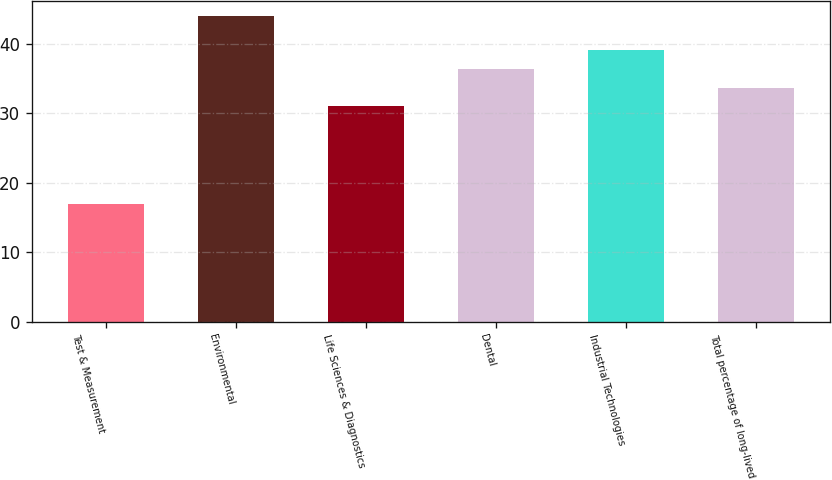Convert chart to OTSL. <chart><loc_0><loc_0><loc_500><loc_500><bar_chart><fcel>Test & Measurement<fcel>Environmental<fcel>Life Sciences & Diagnostics<fcel>Dental<fcel>Industrial Technologies<fcel>Total percentage of long-lived<nl><fcel>17<fcel>44<fcel>31<fcel>36.4<fcel>39.1<fcel>33.7<nl></chart> 